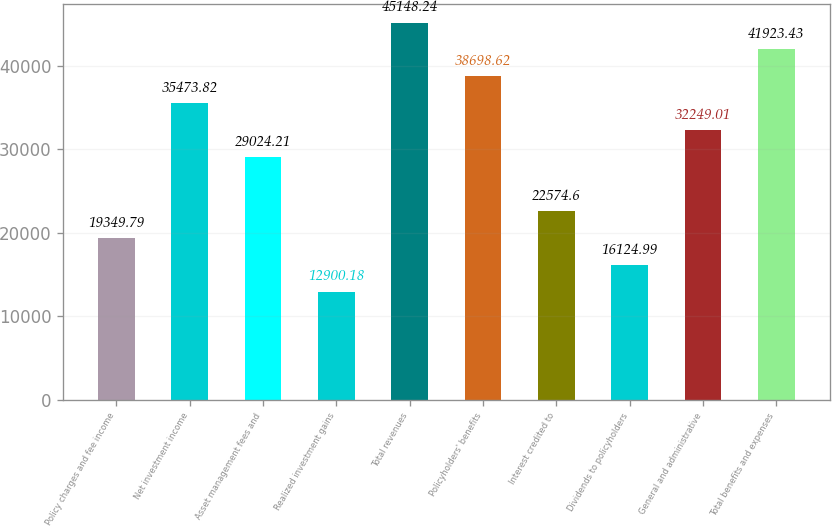<chart> <loc_0><loc_0><loc_500><loc_500><bar_chart><fcel>Policy charges and fee income<fcel>Net investment income<fcel>Asset management fees and<fcel>Realized investment gains<fcel>Total revenues<fcel>Policyholders' benefits<fcel>Interest credited to<fcel>Dividends to policyholders<fcel>General and administrative<fcel>Total benefits and expenses<nl><fcel>19349.8<fcel>35473.8<fcel>29024.2<fcel>12900.2<fcel>45148.2<fcel>38698.6<fcel>22574.6<fcel>16125<fcel>32249<fcel>41923.4<nl></chart> 